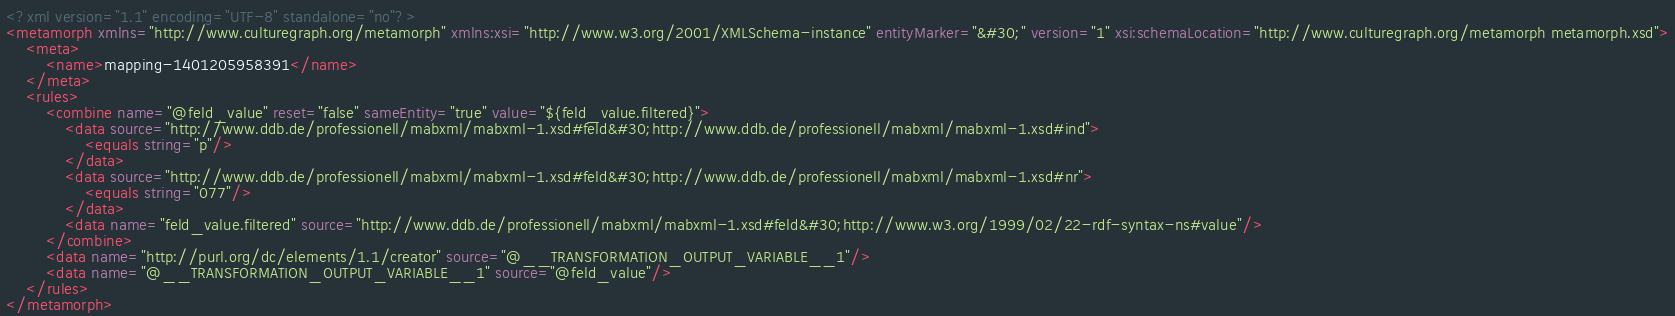Convert code to text. <code><loc_0><loc_0><loc_500><loc_500><_XML_><?xml version="1.1" encoding="UTF-8" standalone="no"?>
<metamorph xmlns="http://www.culturegraph.org/metamorph" xmlns:xsi="http://www.w3.org/2001/XMLSchema-instance" entityMarker="&#30;" version="1" xsi:schemaLocation="http://www.culturegraph.org/metamorph metamorph.xsd">
	<meta>
		<name>mapping-1401205958391</name>
	</meta>
	<rules>
		<combine name="@feld_value" reset="false" sameEntity="true" value="${feld_value.filtered}">
			<data source="http://www.ddb.de/professionell/mabxml/mabxml-1.xsd#feld&#30;http://www.ddb.de/professionell/mabxml/mabxml-1.xsd#ind">
				<equals string="p"/>
			</data>
			<data source="http://www.ddb.de/professionell/mabxml/mabxml-1.xsd#feld&#30;http://www.ddb.de/professionell/mabxml/mabxml-1.xsd#nr">
				<equals string="077"/>
			</data>
			<data name="feld_value.filtered" source="http://www.ddb.de/professionell/mabxml/mabxml-1.xsd#feld&#30;http://www.w3.org/1999/02/22-rdf-syntax-ns#value"/>
		</combine>
		<data name="http://purl.org/dc/elements/1.1/creator" source="@__TRANSFORMATION_OUTPUT_VARIABLE__1"/>
		<data name="@__TRANSFORMATION_OUTPUT_VARIABLE__1" source="@feld_value"/>
	</rules>
</metamorph></code> 